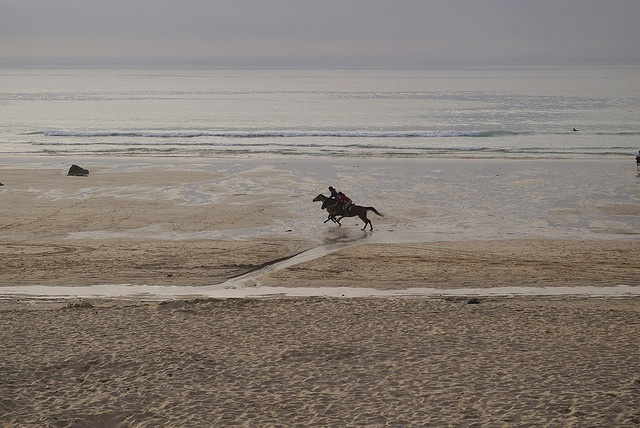Describe the objects in this image and their specific colors. I can see horse in darkgray, black, and gray tones, people in darkgray, black, and gray tones, horse in darkgray, black, and gray tones, people in black, gray, and darkgray tones, and horse in darkgray, black, and gray tones in this image. 